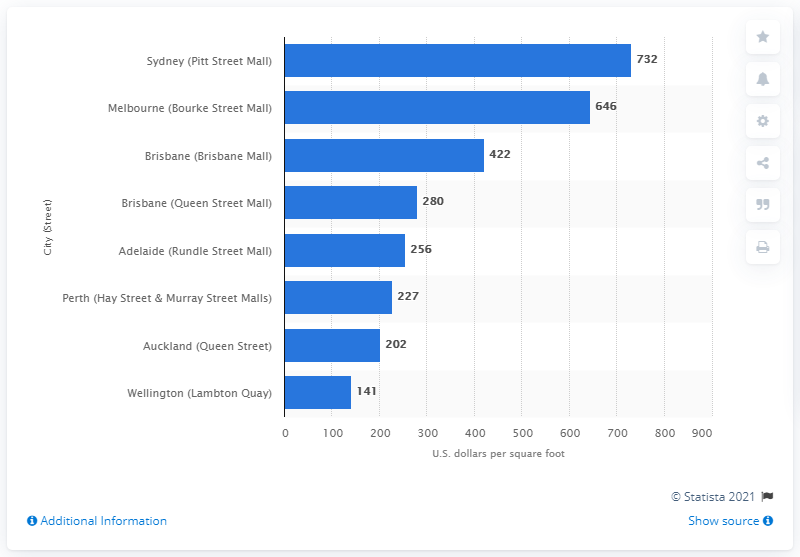List a handful of essential elements in this visual. The cost of rent to own retail in Pitt Street Mall was 732. 